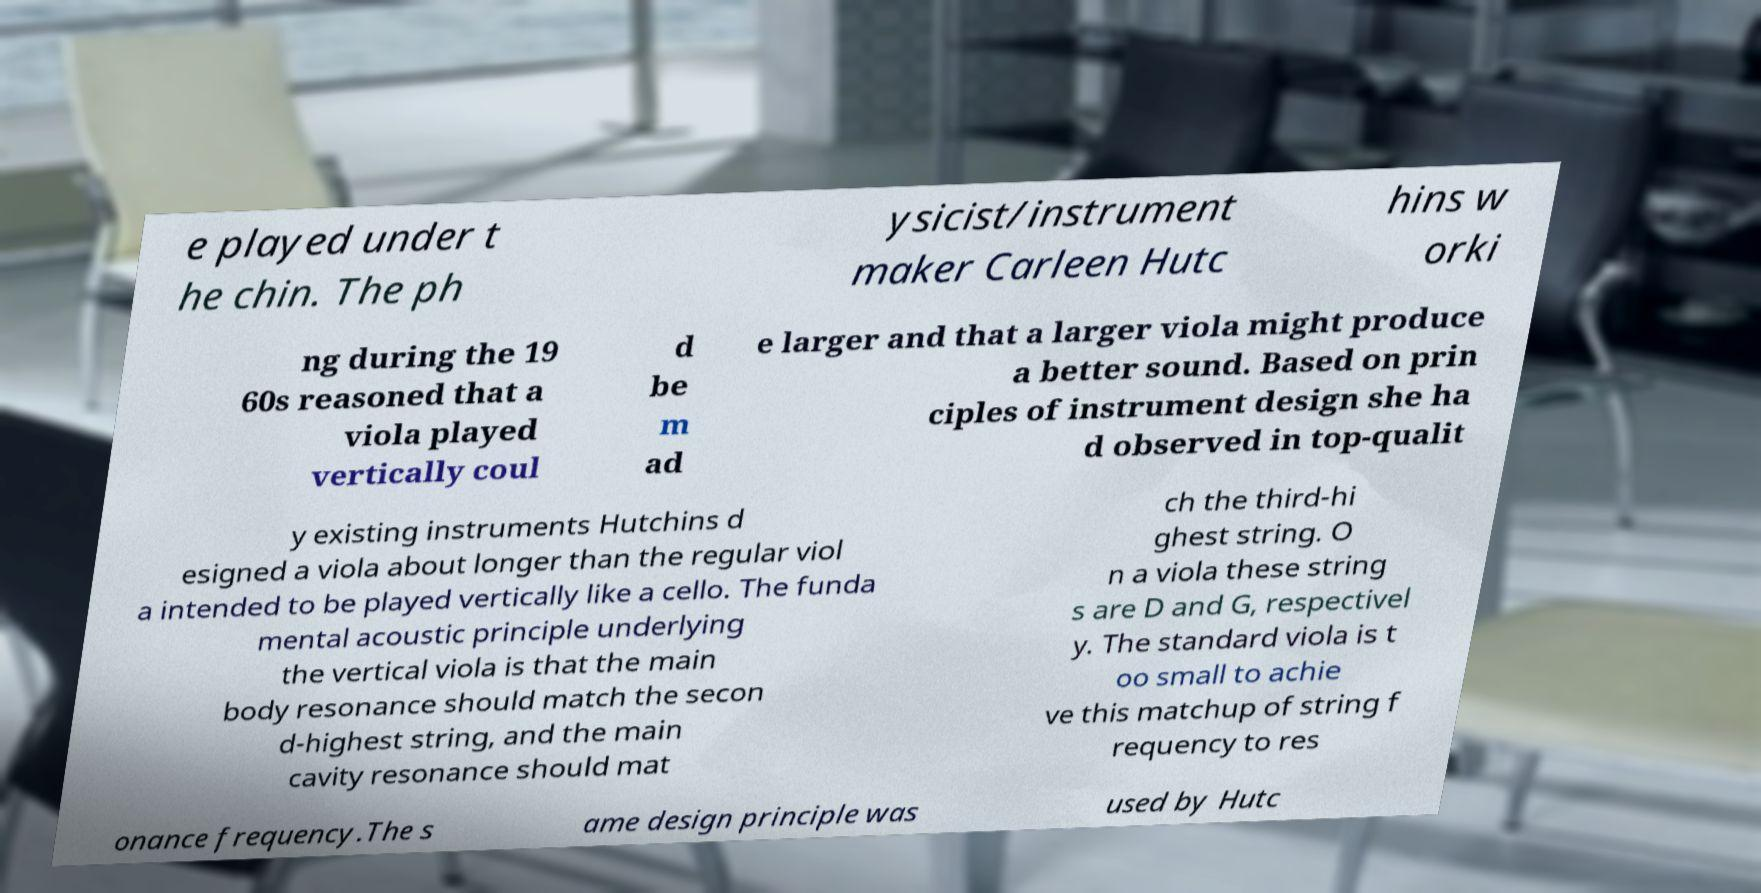Can you read and provide the text displayed in the image?This photo seems to have some interesting text. Can you extract and type it out for me? e played under t he chin. The ph ysicist/instrument maker Carleen Hutc hins w orki ng during the 19 60s reasoned that a viola played vertically coul d be m ad e larger and that a larger viola might produce a better sound. Based on prin ciples of instrument design she ha d observed in top-qualit y existing instruments Hutchins d esigned a viola about longer than the regular viol a intended to be played vertically like a cello. The funda mental acoustic principle underlying the vertical viola is that the main body resonance should match the secon d-highest string, and the main cavity resonance should mat ch the third-hi ghest string. O n a viola these string s are D and G, respectivel y. The standard viola is t oo small to achie ve this matchup of string f requency to res onance frequency.The s ame design principle was used by Hutc 